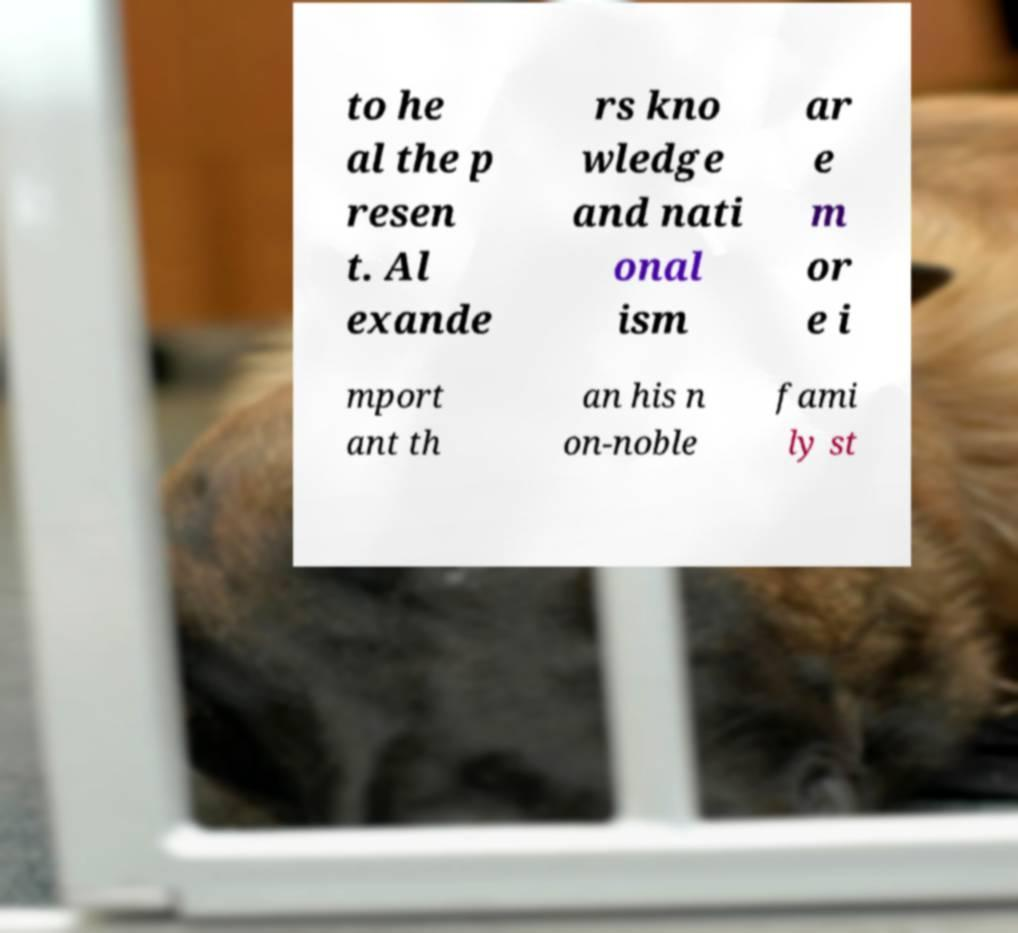Please read and relay the text visible in this image. What does it say? to he al the p resen t. Al exande rs kno wledge and nati onal ism ar e m or e i mport ant th an his n on-noble fami ly st 